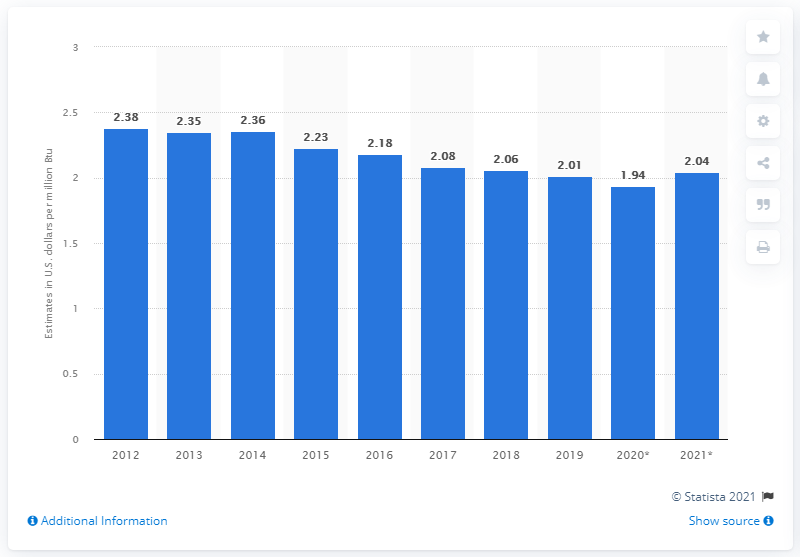Indicate a few pertinent items in this graphic. The expected price of coal for electric power generation in the United States in 2020 is estimated to be $1.94 per million British thermal units. 